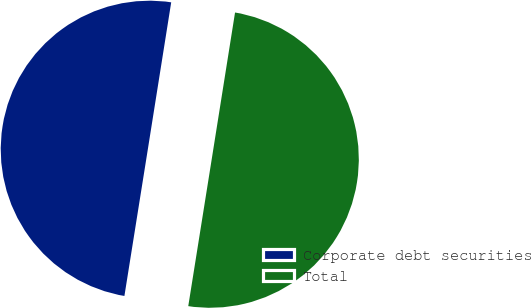Convert chart to OTSL. <chart><loc_0><loc_0><loc_500><loc_500><pie_chart><fcel>Corporate debt securities<fcel>Total<nl><fcel>49.99%<fcel>50.01%<nl></chart> 